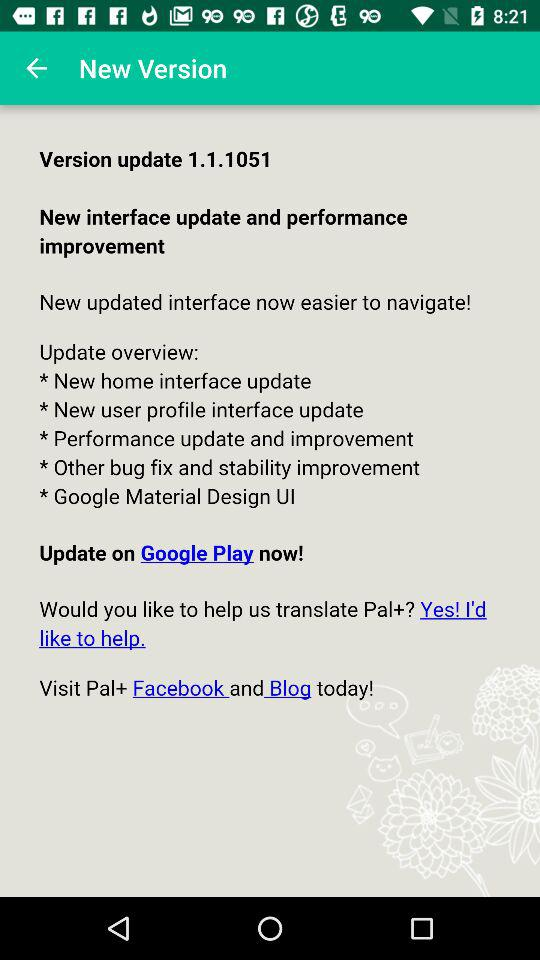How many updates are there in the update overview?
Answer the question using a single word or phrase. 5 